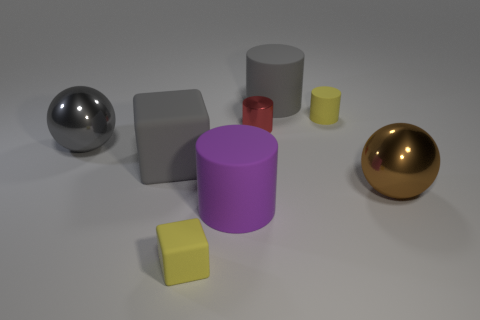Do the sphere behind the large brown metallic object and the rubber cylinder that is in front of the gray sphere have the same size?
Provide a succinct answer. Yes. The big metal object behind the brown metal ball has what shape?
Provide a short and direct response. Sphere. What color is the metallic cylinder?
Your response must be concise. Red. Is the size of the purple object the same as the metallic ball that is behind the brown thing?
Your response must be concise. Yes. What number of metal objects are tiny yellow objects or brown objects?
Offer a terse response. 1. Does the small matte block have the same color as the metallic object to the left of the tiny red metallic thing?
Offer a terse response. No. What shape is the brown thing?
Your answer should be very brief. Sphere. There is a purple matte cylinder that is behind the rubber block in front of the big metal thing that is in front of the big gray metal sphere; what is its size?
Keep it short and to the point. Large. What number of other things are the same shape as the purple matte thing?
Offer a very short reply. 3. Do the tiny thing in front of the brown metallic thing and the big matte thing that is in front of the large gray block have the same shape?
Your response must be concise. No. 